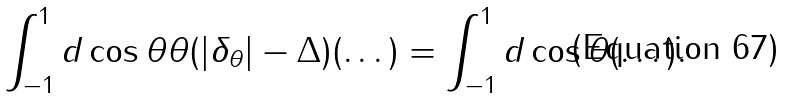<formula> <loc_0><loc_0><loc_500><loc_500>\int _ { - 1 } ^ { 1 } d \cos \theta \theta ( | \delta _ { \theta } | - \Delta ) ( \dots ) = \int _ { - 1 } ^ { 1 } d \cos \theta ( \dots ) .</formula> 